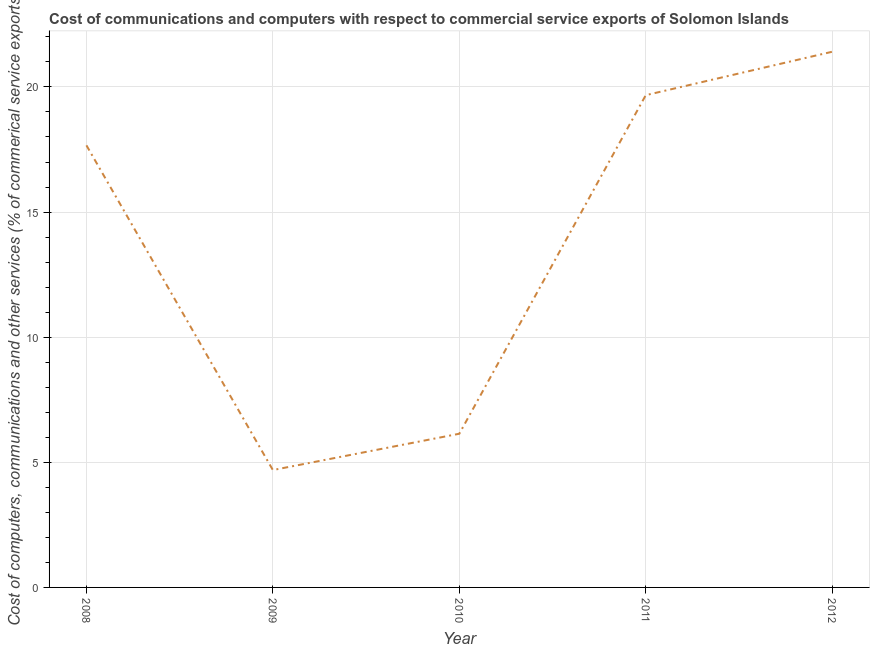What is the cost of communications in 2008?
Your response must be concise. 17.67. Across all years, what is the maximum  computer and other services?
Provide a succinct answer. 21.41. Across all years, what is the minimum cost of communications?
Provide a succinct answer. 4.69. In which year was the  computer and other services maximum?
Provide a succinct answer. 2012. What is the sum of the cost of communications?
Provide a short and direct response. 69.58. What is the difference between the  computer and other services in 2010 and 2011?
Your response must be concise. -13.53. What is the average  computer and other services per year?
Provide a succinct answer. 13.92. What is the median  computer and other services?
Your answer should be compact. 17.67. Do a majority of the years between 2009 and 2008 (inclusive) have  computer and other services greater than 19 %?
Ensure brevity in your answer.  No. What is the ratio of the  computer and other services in 2009 to that in 2012?
Give a very brief answer. 0.22. Is the cost of communications in 2008 less than that in 2011?
Provide a short and direct response. Yes. What is the difference between the highest and the second highest  computer and other services?
Give a very brief answer. 1.74. Is the sum of the cost of communications in 2008 and 2012 greater than the maximum cost of communications across all years?
Your response must be concise. Yes. What is the difference between the highest and the lowest  computer and other services?
Keep it short and to the point. 16.72. How many lines are there?
Offer a very short reply. 1. What is the difference between two consecutive major ticks on the Y-axis?
Your answer should be compact. 5. What is the title of the graph?
Provide a short and direct response. Cost of communications and computers with respect to commercial service exports of Solomon Islands. What is the label or title of the Y-axis?
Your answer should be very brief. Cost of computers, communications and other services (% of commerical service exports). What is the Cost of computers, communications and other services (% of commerical service exports) of 2008?
Keep it short and to the point. 17.67. What is the Cost of computers, communications and other services (% of commerical service exports) in 2009?
Give a very brief answer. 4.69. What is the Cost of computers, communications and other services (% of commerical service exports) of 2010?
Ensure brevity in your answer.  6.14. What is the Cost of computers, communications and other services (% of commerical service exports) in 2011?
Give a very brief answer. 19.67. What is the Cost of computers, communications and other services (% of commerical service exports) in 2012?
Offer a terse response. 21.41. What is the difference between the Cost of computers, communications and other services (% of commerical service exports) in 2008 and 2009?
Your answer should be compact. 12.98. What is the difference between the Cost of computers, communications and other services (% of commerical service exports) in 2008 and 2010?
Make the answer very short. 11.53. What is the difference between the Cost of computers, communications and other services (% of commerical service exports) in 2008 and 2011?
Offer a very short reply. -2. What is the difference between the Cost of computers, communications and other services (% of commerical service exports) in 2008 and 2012?
Give a very brief answer. -3.74. What is the difference between the Cost of computers, communications and other services (% of commerical service exports) in 2009 and 2010?
Provide a succinct answer. -1.45. What is the difference between the Cost of computers, communications and other services (% of commerical service exports) in 2009 and 2011?
Provide a short and direct response. -14.98. What is the difference between the Cost of computers, communications and other services (% of commerical service exports) in 2009 and 2012?
Offer a terse response. -16.72. What is the difference between the Cost of computers, communications and other services (% of commerical service exports) in 2010 and 2011?
Make the answer very short. -13.53. What is the difference between the Cost of computers, communications and other services (% of commerical service exports) in 2010 and 2012?
Give a very brief answer. -15.26. What is the difference between the Cost of computers, communications and other services (% of commerical service exports) in 2011 and 2012?
Offer a very short reply. -1.74. What is the ratio of the Cost of computers, communications and other services (% of commerical service exports) in 2008 to that in 2009?
Ensure brevity in your answer.  3.77. What is the ratio of the Cost of computers, communications and other services (% of commerical service exports) in 2008 to that in 2010?
Provide a short and direct response. 2.88. What is the ratio of the Cost of computers, communications and other services (% of commerical service exports) in 2008 to that in 2011?
Make the answer very short. 0.9. What is the ratio of the Cost of computers, communications and other services (% of commerical service exports) in 2008 to that in 2012?
Give a very brief answer. 0.82. What is the ratio of the Cost of computers, communications and other services (% of commerical service exports) in 2009 to that in 2010?
Offer a terse response. 0.76. What is the ratio of the Cost of computers, communications and other services (% of commerical service exports) in 2009 to that in 2011?
Provide a succinct answer. 0.24. What is the ratio of the Cost of computers, communications and other services (% of commerical service exports) in 2009 to that in 2012?
Offer a very short reply. 0.22. What is the ratio of the Cost of computers, communications and other services (% of commerical service exports) in 2010 to that in 2011?
Give a very brief answer. 0.31. What is the ratio of the Cost of computers, communications and other services (% of commerical service exports) in 2010 to that in 2012?
Offer a terse response. 0.29. What is the ratio of the Cost of computers, communications and other services (% of commerical service exports) in 2011 to that in 2012?
Provide a succinct answer. 0.92. 